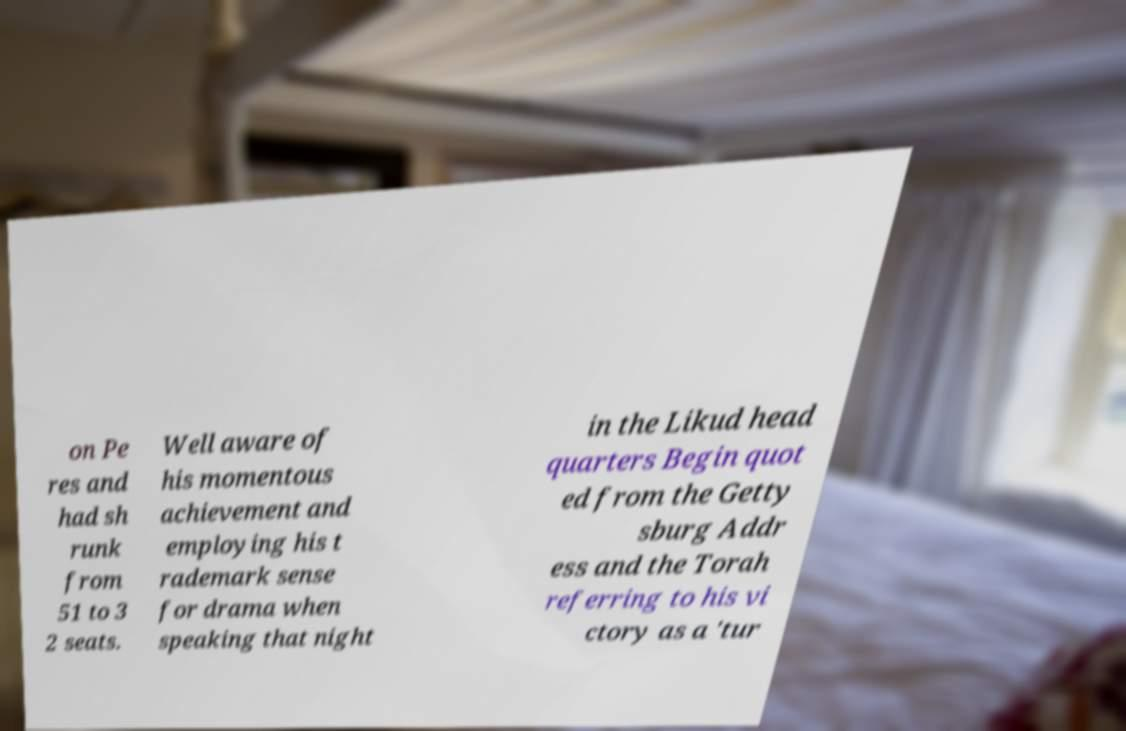For documentation purposes, I need the text within this image transcribed. Could you provide that? on Pe res and had sh runk from 51 to 3 2 seats. Well aware of his momentous achievement and employing his t rademark sense for drama when speaking that night in the Likud head quarters Begin quot ed from the Getty sburg Addr ess and the Torah referring to his vi ctory as a 'tur 